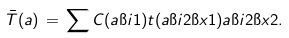Convert formula to latex. <formula><loc_0><loc_0><loc_500><loc_500>\bar { T } ( a ) \, = \, \sum C ( a \i i 1 ) t ( a \i i 2 \i x 1 ) a \i i 2 \i x 2 .</formula> 